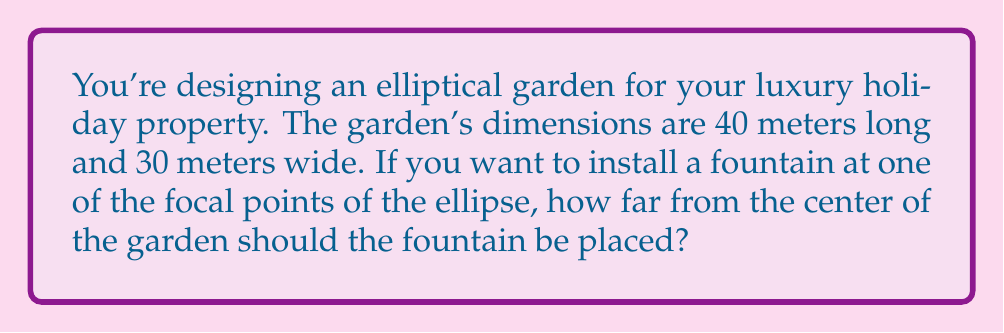Help me with this question. Let's approach this step-by-step using the properties of ellipses:

1) The equation of an ellipse with center at the origin is:

   $$\frac{x^2}{a^2} + \frac{y^2}{b^2} = 1$$

   where $a$ is the semi-major axis and $b$ is the semi-minor axis.

2) In this case, the length is 40m and the width is 30m, so:
   $a = 20$ (half of 40)
   $b = 15$ (half of 30)

3) For an ellipse, the distance $c$ from the center to a focal point is given by:

   $$c^2 = a^2 - b^2$$

4) Substituting our values:

   $$c^2 = 20^2 - 15^2 = 400 - 225 = 175$$

5) Taking the square root:

   $$c = \sqrt{175} = 5\sqrt{7} \approx 13.23$$

Therefore, the fountain should be placed approximately 13.23 meters from the center of the garden.

[asy]
size(200);
pen ellipsePen = darkblue+1;
pen axesPen = gray+0.5;
pen pointPen = red+3;

draw(ellipse((0,0), 20, 15), ellipsePen);
draw((-22,0)--(22,0), axesPen);
draw((0,-17)--(0,17), axesPen);

dot((13.23,0), pointPen);
dot((-13.23,0), pointPen);

label("Fountain", (13.23,0), E);
label("20m", (0,15), N);
label("15m", (20,0), E);

[/asy]
Answer: The fountain should be placed $5\sqrt{7} \approx 13.23$ meters from the center of the garden. 